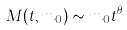Convert formula to latex. <formula><loc_0><loc_0><loc_500><loc_500>M ( t , m _ { 0 } ) \sim m _ { 0 } t ^ { \theta }</formula> 